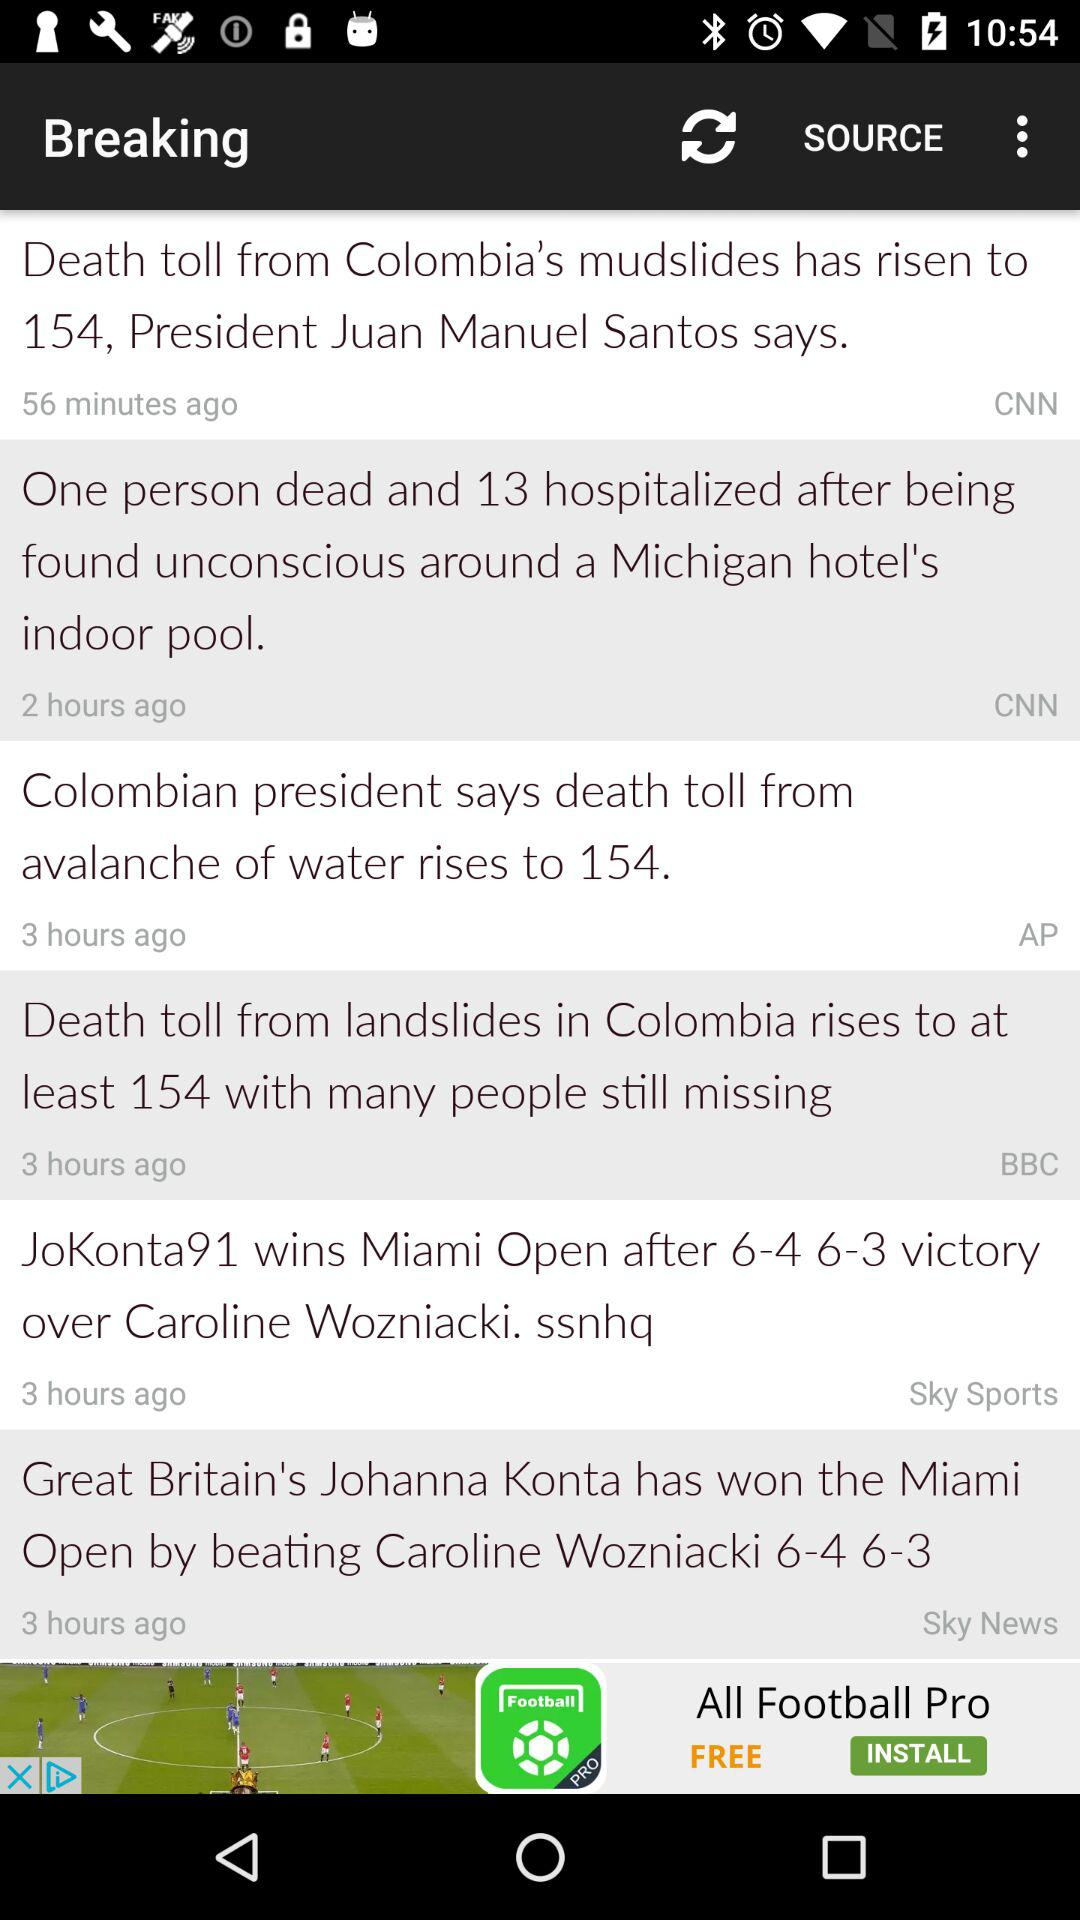How many news items are from CNN?
Answer the question using a single word or phrase. 2 